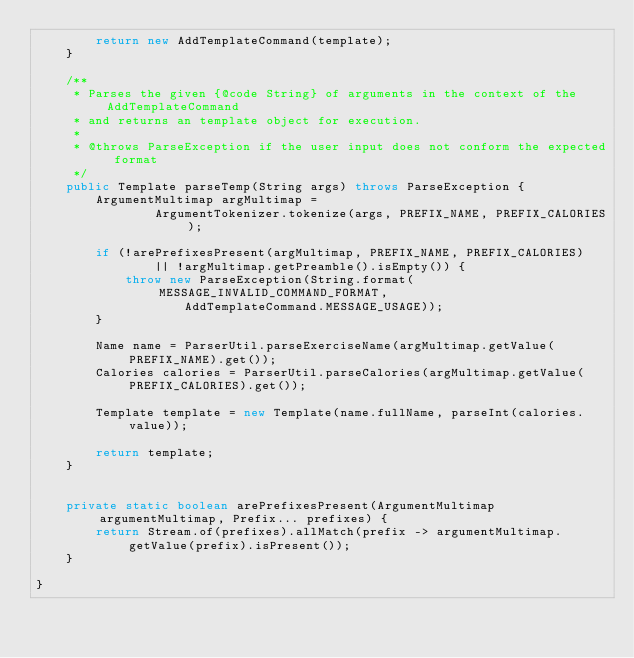<code> <loc_0><loc_0><loc_500><loc_500><_Java_>        return new AddTemplateCommand(template);
    }

    /**
     * Parses the given {@code String} of arguments in the context of the AddTemplateCommand
     * and returns an template object for execution.
     *
     * @throws ParseException if the user input does not conform the expected format
     */
    public Template parseTemp(String args) throws ParseException {
        ArgumentMultimap argMultimap =
                ArgumentTokenizer.tokenize(args, PREFIX_NAME, PREFIX_CALORIES);

        if (!arePrefixesPresent(argMultimap, PREFIX_NAME, PREFIX_CALORIES)
                || !argMultimap.getPreamble().isEmpty()) {
            throw new ParseException(String.format(MESSAGE_INVALID_COMMAND_FORMAT,
                    AddTemplateCommand.MESSAGE_USAGE));
        }

        Name name = ParserUtil.parseExerciseName(argMultimap.getValue(PREFIX_NAME).get());
        Calories calories = ParserUtil.parseCalories(argMultimap.getValue(PREFIX_CALORIES).get());

        Template template = new Template(name.fullName, parseInt(calories.value));

        return template;
    }


    private static boolean arePrefixesPresent(ArgumentMultimap argumentMultimap, Prefix... prefixes) {
        return Stream.of(prefixes).allMatch(prefix -> argumentMultimap.getValue(prefix).isPresent());
    }

}
</code> 